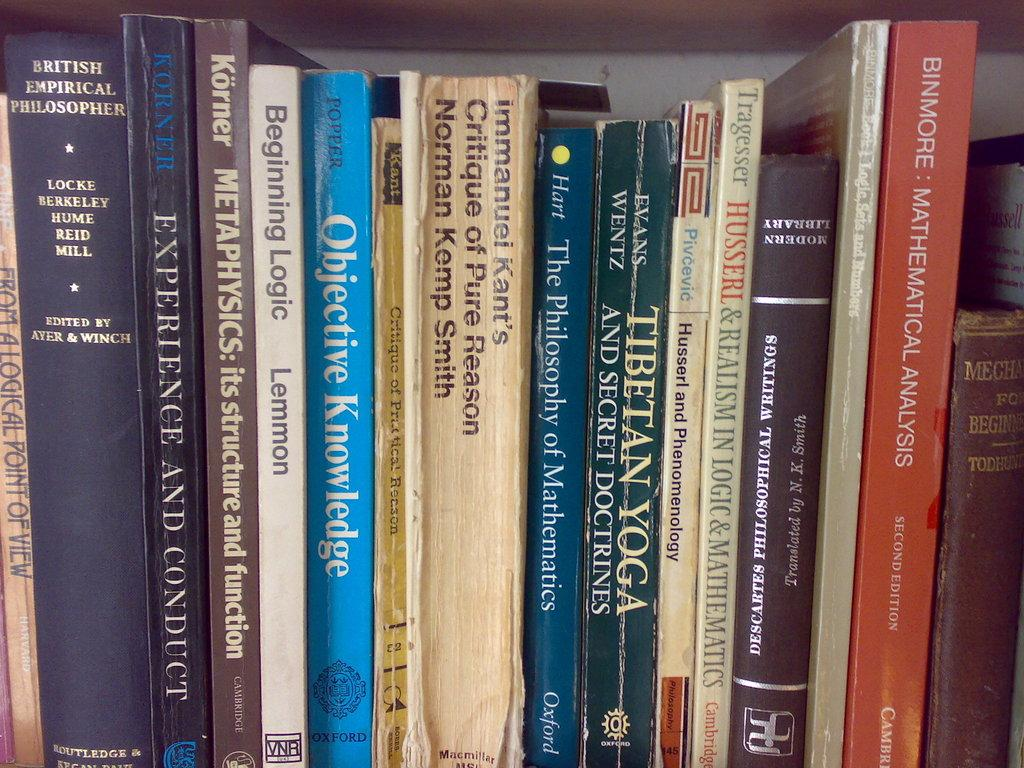<image>
Present a compact description of the photo's key features. A stack of books on a shelf including the book Objective Knowledge 